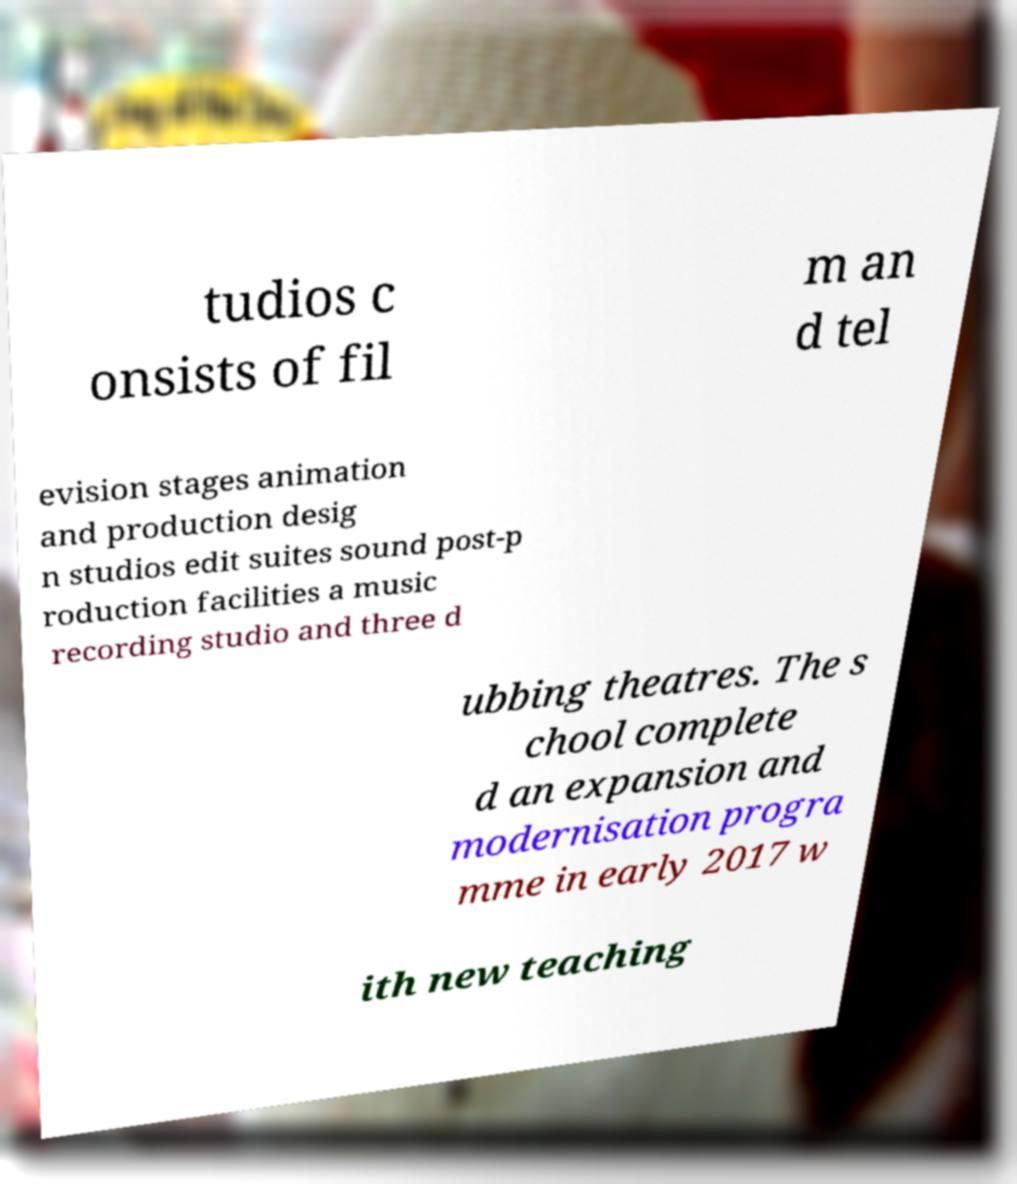Could you assist in decoding the text presented in this image and type it out clearly? tudios c onsists of fil m an d tel evision stages animation and production desig n studios edit suites sound post-p roduction facilities a music recording studio and three d ubbing theatres. The s chool complete d an expansion and modernisation progra mme in early 2017 w ith new teaching 